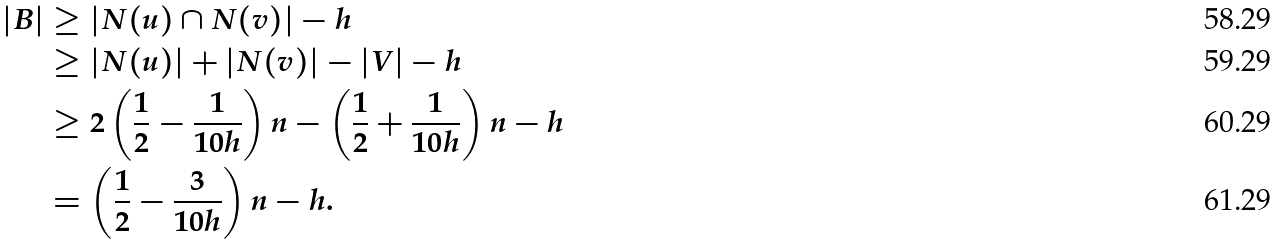<formula> <loc_0><loc_0><loc_500><loc_500>| B | & \geq | N ( u ) \cap N ( v ) | - h \\ & \geq | N ( u ) | + | N ( v ) | - | V | - h \\ & \geq 2 \left ( \frac { 1 } { 2 } - \frac { 1 } { 1 0 h } \right ) n - \left ( \frac { 1 } { 2 } + \frac { 1 } { 1 0 h } \right ) n - h \\ & = \left ( \frac { 1 } { 2 } - \frac { 3 } { 1 0 h } \right ) n - h .</formula> 